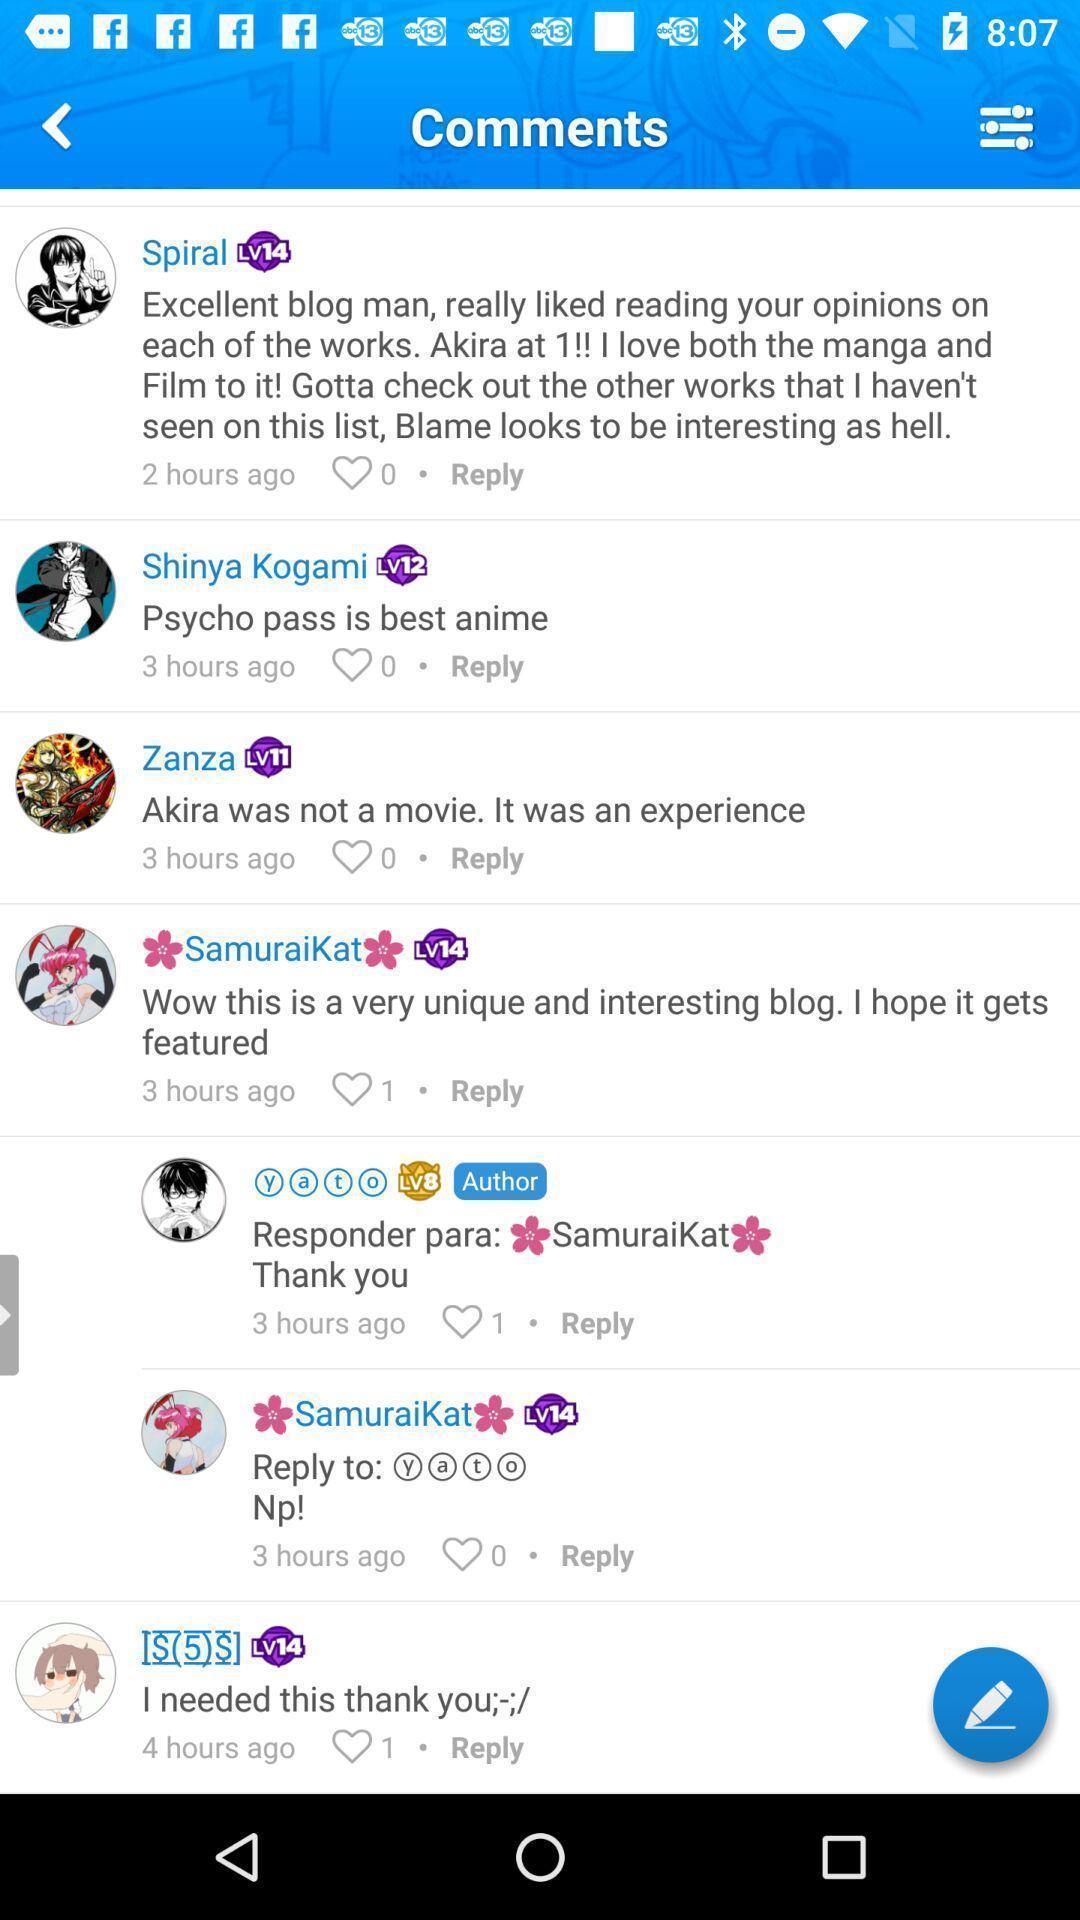Describe the content in this image. Page showing multiple comments in app. 